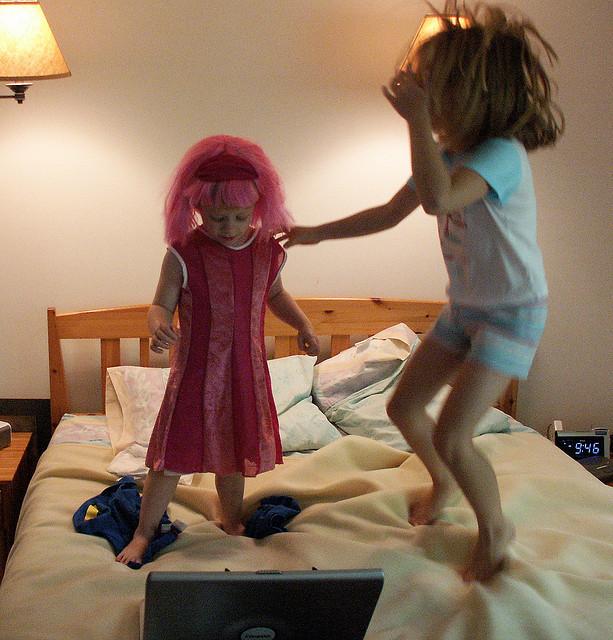Is that her natural hair?
Keep it brief. No. What are the kids looking at?
Keep it brief. Laptop. How many pillowcases are there?
Keep it brief. 2. 